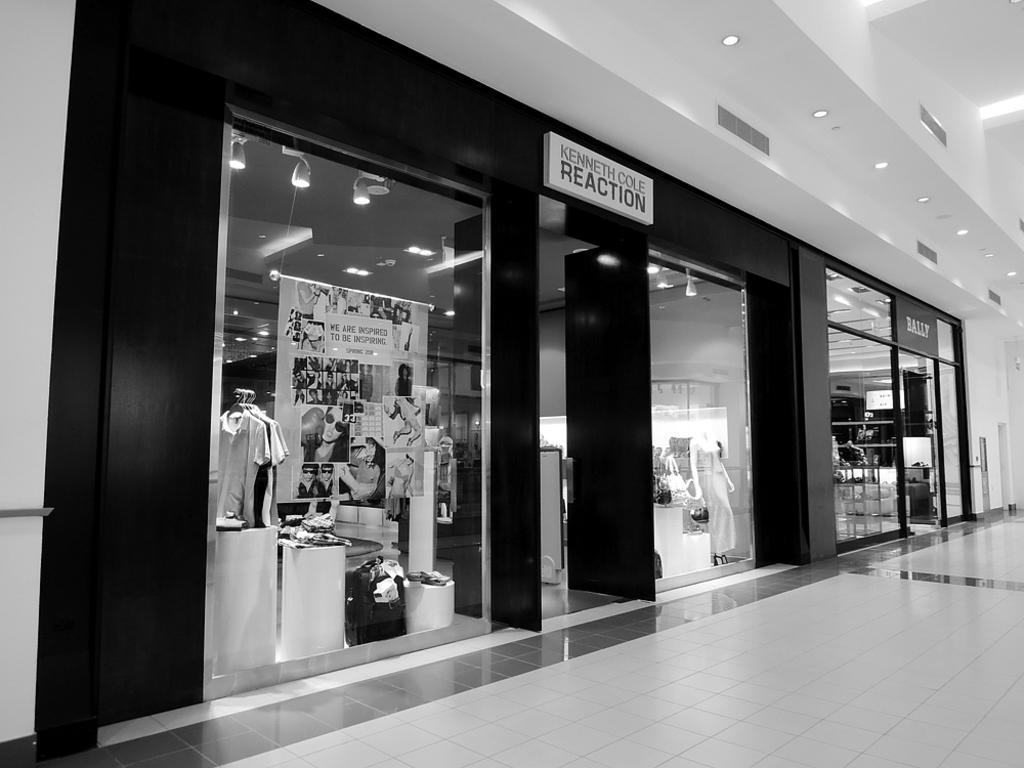Can you describe this image briefly? In the foreground of this image, on the bottom there is the floor. In the background, there are shops and in side there is a banner, clothes to the hangers, lights, ceiling, a mannequin and text on the top of the shop. On the right top corner, there is ceiling and lights. 